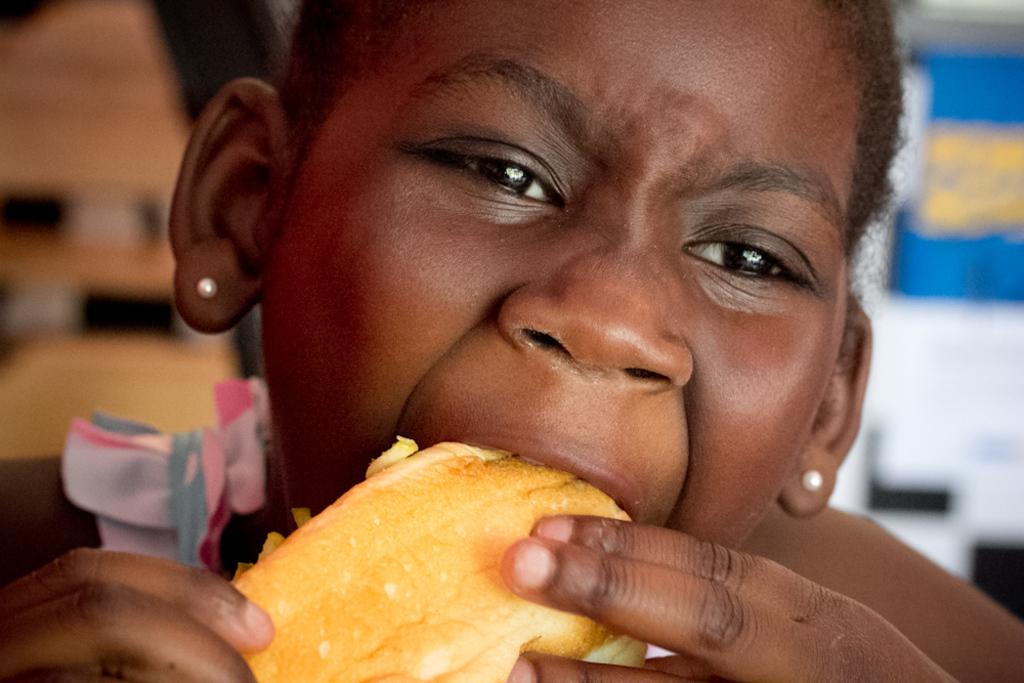Who or what is the main subject in the image? There is a person in the image. What is the person doing in the image? The person is eating a food item. Can you describe the background of the image? The background of the image is blurred. What type of pie is being served in the image? There is no pie present in the image; the person is eating a food item, but it is not specified as a pie. 